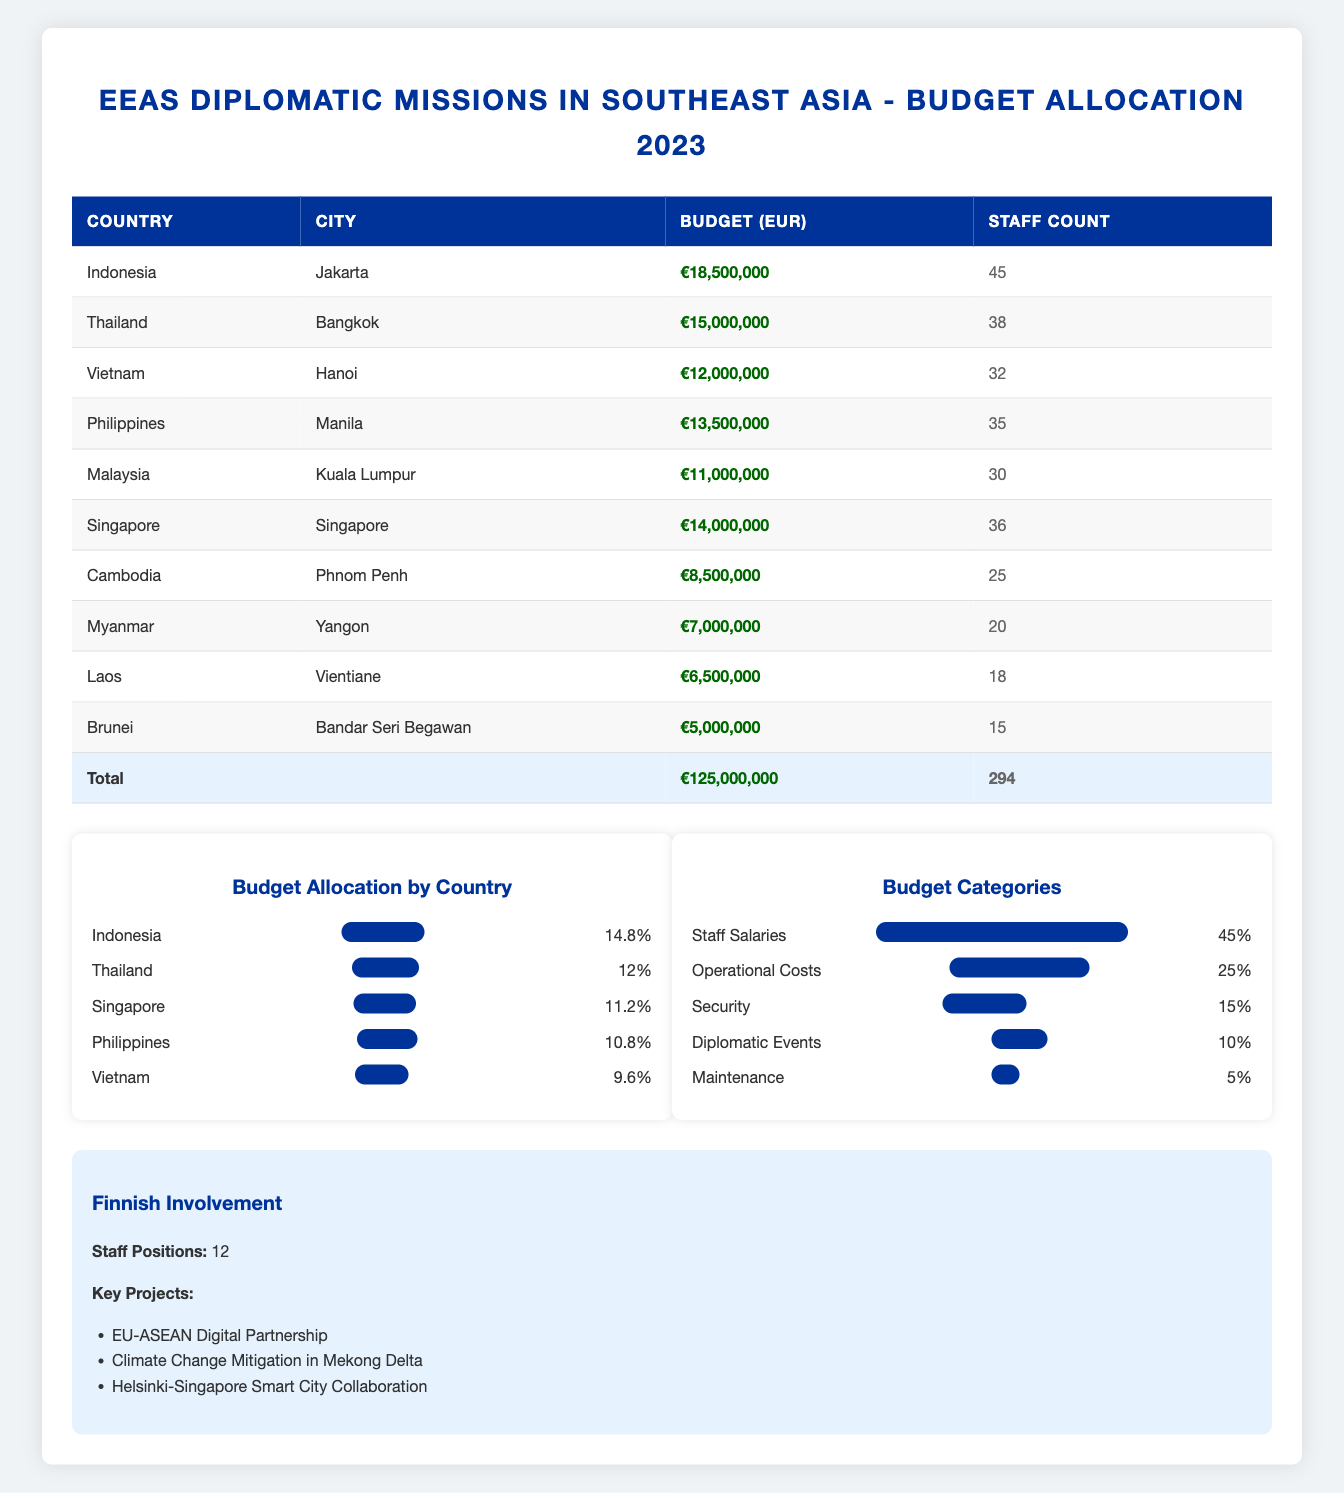What is the total budget allocation for EEAS diplomatic missions in Southeast Asia in 2023? The total budget is mentioned at the bottom of the table, which states it is €125,000,000.
Answer: €125,000,000 Which country has the highest budget allocation among the listed missions? By comparing the budget values, Indonesia has the highest budget allocation of €18,500,000, which is greater than all other countries listed.
Answer: Indonesia How many staff members are assigned to the mission in Thailand? The table directly states that the staff count for Thailand is 38.
Answer: 38 What percentage of the total budget is allocated to staff salaries? According to the budget categories, 45% of the total budget is allocated to staff salaries.
Answer: 45% If we consider only the budgets of Indonesia, Thailand, and Vietnam, what is their combined budget? The budgets for these three countries are €18,500,000 (Indonesia), €15,000,000 (Thailand), and €12,000,000 (Vietnam). The combined budget is calculated as: €18,500,000 + €15,000,000 + €12,000,000 = €45,500,000.
Answer: €45,500,000 Is the budget for Cambodia greater than the budget for Laos? Looking at the table, Cambodia's budget is €8,500,000, and Laos' budget is €6,500,000. Since €8,500,000 is greater than €6,500,000, the answer is yes.
Answer: Yes What is the average budget allocation for the missions listed in the table? There are 10 missions total, and the total budget is €125,000,000. To find the average, divide the total budget by the number of missions: €125,000,000 / 10 = €12,500,000.
Answer: €12,500,000 Which category of budget eats up the largest portion of the total budget? According to the budget categories, staff salaries consume 45% of the total budget, which is more than any other category such as operational costs at 25%.
Answer: Staff Salaries How many missions have a budget of less than €10,000,000? The table shows that Myanmar (€7,000,000), Laos (€6,500,000), and Brunei (€5,000,000) have budgets less than €10,000,000. Counting these gives us three missions.
Answer: 3 What is the total staff count across all missions in Southeast Asia? The staff counts for all missions are as follows: 45 (Indonesia) + 38 (Thailand) + 32 (Vietnam) + 35 (Philippines) + 30 (Malaysia) + 36 (Singapore) + 25 (Cambodia) + 20 (Myanmar) + 18 (Laos) + 15 (Brunei), which totals to 294.
Answer: 294 